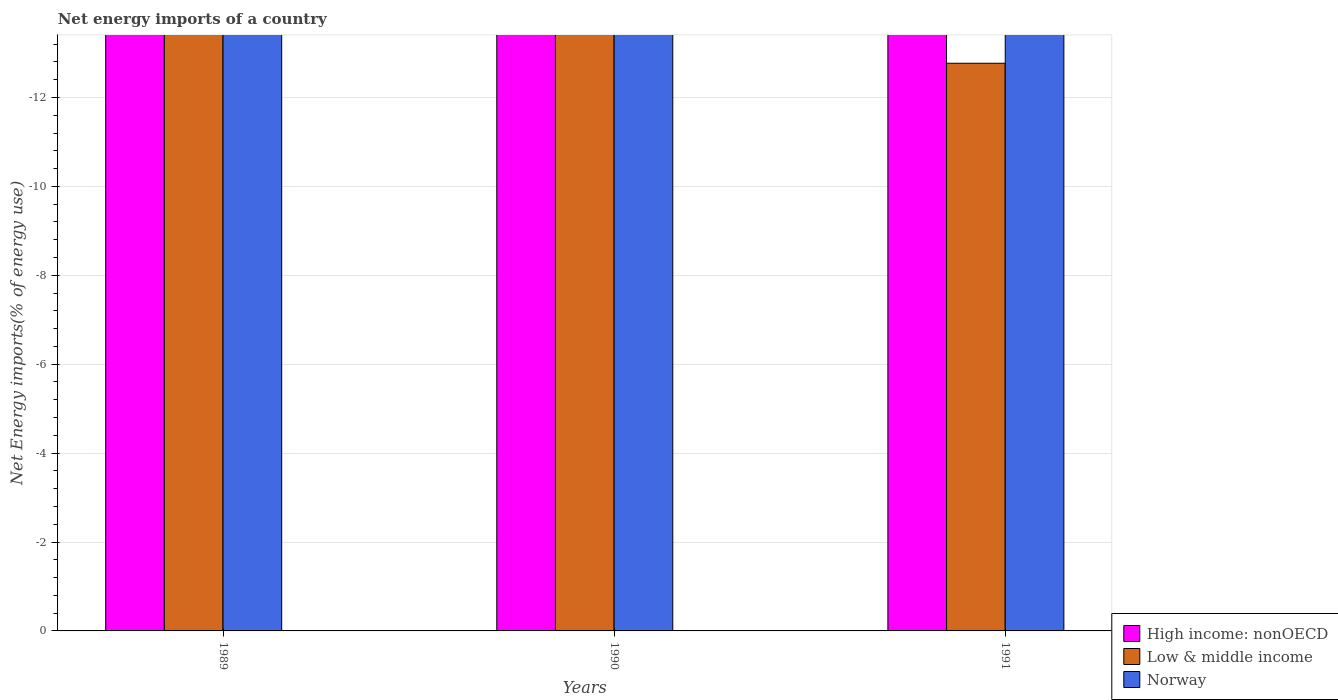How many different coloured bars are there?
Offer a very short reply. 0. Are the number of bars per tick equal to the number of legend labels?
Offer a very short reply. No. Are the number of bars on each tick of the X-axis equal?
Provide a succinct answer. Yes. How many bars are there on the 3rd tick from the left?
Offer a very short reply. 0. What is the label of the 2nd group of bars from the left?
Make the answer very short. 1990. In how many cases, is the number of bars for a given year not equal to the number of legend labels?
Keep it short and to the point. 3. What is the net energy imports in Norway in 1990?
Give a very brief answer. 0. Across all years, what is the minimum net energy imports in Norway?
Provide a succinct answer. 0. What is the total net energy imports in High income: nonOECD in the graph?
Ensure brevity in your answer.  0. What is the difference between the net energy imports in Norway in 1989 and the net energy imports in High income: nonOECD in 1990?
Your answer should be very brief. 0. What is the average net energy imports in Low & middle income per year?
Ensure brevity in your answer.  0. Is it the case that in every year, the sum of the net energy imports in High income: nonOECD and net energy imports in Low & middle income is greater than the net energy imports in Norway?
Offer a very short reply. No. How many bars are there?
Offer a terse response. 0. Are all the bars in the graph horizontal?
Ensure brevity in your answer.  No. Where does the legend appear in the graph?
Offer a terse response. Bottom right. How many legend labels are there?
Offer a terse response. 3. What is the title of the graph?
Offer a very short reply. Net energy imports of a country. Does "Madagascar" appear as one of the legend labels in the graph?
Your answer should be compact. No. What is the label or title of the X-axis?
Your answer should be very brief. Years. What is the label or title of the Y-axis?
Provide a succinct answer. Net Energy imports(% of energy use). What is the Net Energy imports(% of energy use) of High income: nonOECD in 1989?
Provide a succinct answer. 0. What is the Net Energy imports(% of energy use) in Low & middle income in 1989?
Make the answer very short. 0. What is the Net Energy imports(% of energy use) in Norway in 1989?
Offer a very short reply. 0. What is the Net Energy imports(% of energy use) of High income: nonOECD in 1990?
Offer a terse response. 0. What is the Net Energy imports(% of energy use) of Low & middle income in 1990?
Provide a short and direct response. 0. What is the Net Energy imports(% of energy use) of High income: nonOECD in 1991?
Offer a terse response. 0. What is the Net Energy imports(% of energy use) of Low & middle income in 1991?
Ensure brevity in your answer.  0. What is the total Net Energy imports(% of energy use) of Low & middle income in the graph?
Ensure brevity in your answer.  0. What is the average Net Energy imports(% of energy use) of High income: nonOECD per year?
Keep it short and to the point. 0. What is the average Net Energy imports(% of energy use) of Low & middle income per year?
Ensure brevity in your answer.  0. 